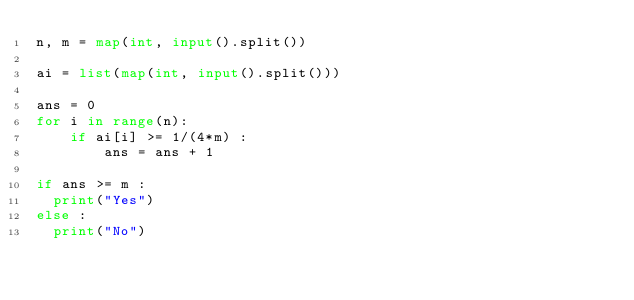Convert code to text. <code><loc_0><loc_0><loc_500><loc_500><_Python_>n, m = map(int, input().split())

ai = list(map(int, input().split()))

ans = 0
for i in range(n):
    if ai[i] >= 1/(4*m) :
        ans = ans + 1

if ans >= m :
  print("Yes")
else :
  print("No")
</code> 